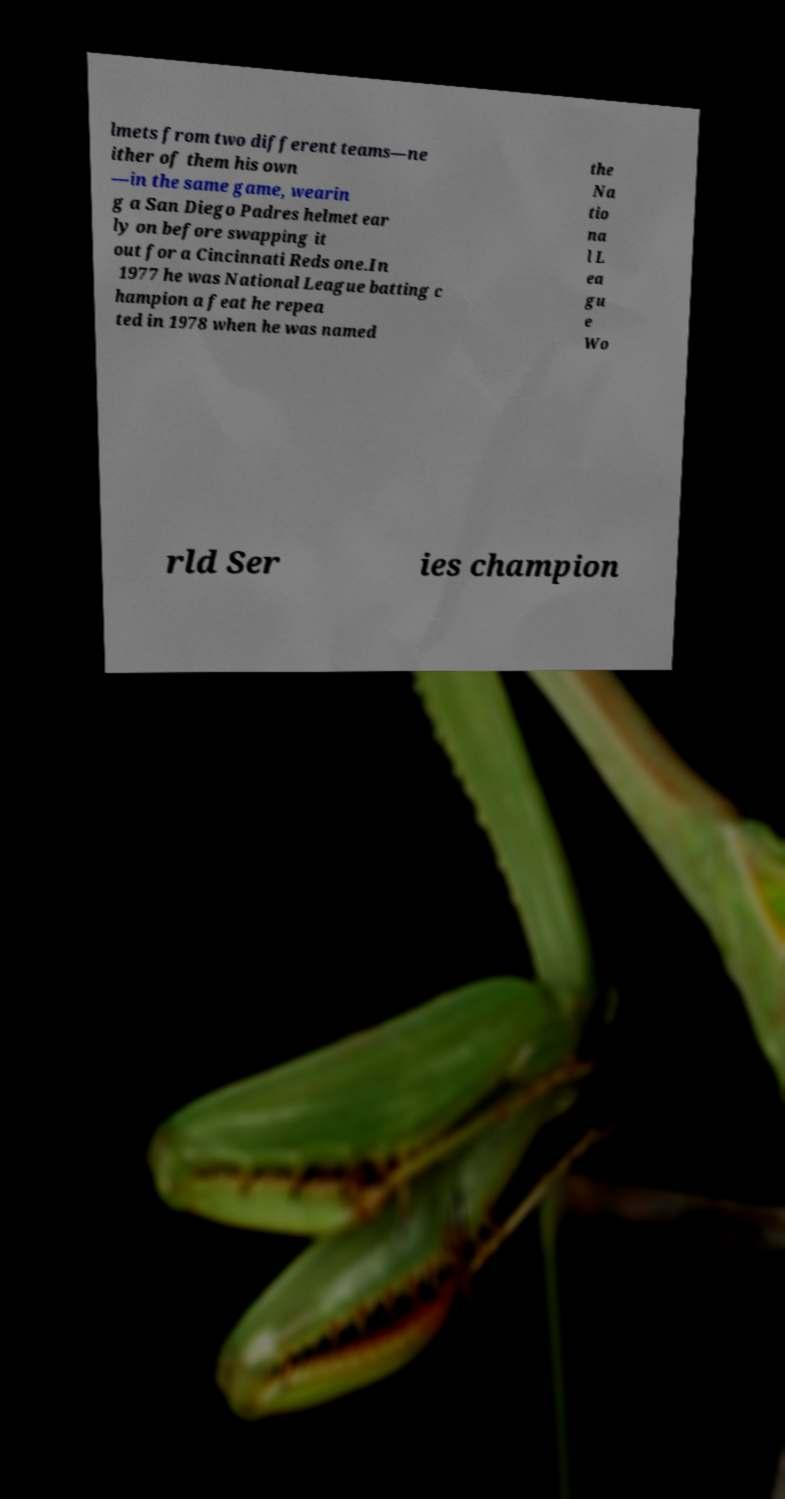Can you read and provide the text displayed in the image?This photo seems to have some interesting text. Can you extract and type it out for me? lmets from two different teams—ne ither of them his own —in the same game, wearin g a San Diego Padres helmet ear ly on before swapping it out for a Cincinnati Reds one.In 1977 he was National League batting c hampion a feat he repea ted in 1978 when he was named the Na tio na l L ea gu e Wo rld Ser ies champion 